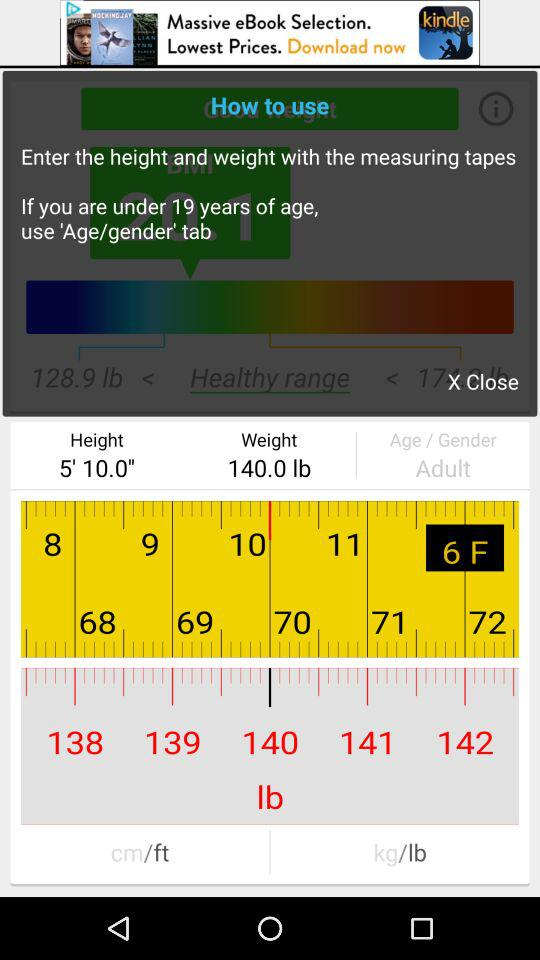What is the weight? The weight is 140 pounds. 